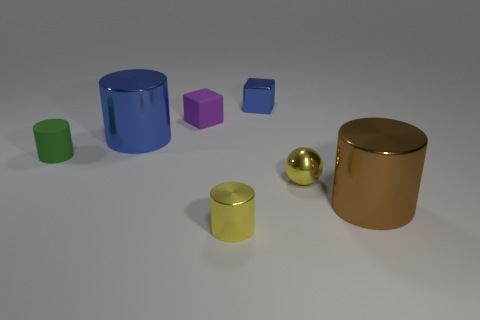Subtract all green rubber cylinders. How many cylinders are left? 3 Subtract all brown cylinders. How many cylinders are left? 3 Add 2 cyan rubber objects. How many objects exist? 9 Subtract all brown cylinders. Subtract all gray cubes. How many cylinders are left? 3 Subtract 1 purple cubes. How many objects are left? 6 Subtract all balls. How many objects are left? 6 Subtract all tiny brown rubber things. Subtract all yellow cylinders. How many objects are left? 6 Add 6 small green rubber things. How many small green rubber things are left? 7 Add 1 tiny metal balls. How many tiny metal balls exist? 2 